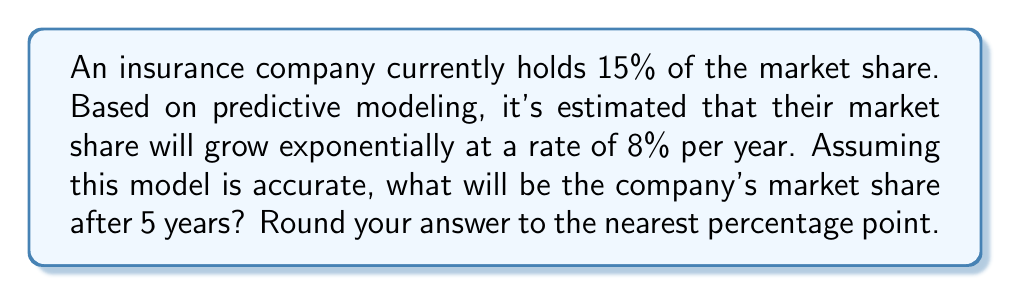Can you answer this question? To solve this problem, we'll use the exponential growth formula:

$$ A = P(1 + r)^t $$

Where:
$A$ = Final amount
$P$ = Initial amount (starting market share)
$r$ = Growth rate (as a decimal)
$t$ = Time period

Given:
$P = 15\%$ (or 0.15 as a decimal)
$r = 8\%$ (or 0.08 as a decimal)
$t = 5$ years

Let's plug these values into the formula:

$$ A = 0.15(1 + 0.08)^5 $$

Now, let's calculate step-by-step:

1) First, calculate $(1 + 0.08)^5$:
   $$ (1.08)^5 = 1.46933 $$

2) Multiply this result by the initial market share:
   $$ 0.15 \times 1.46933 = 0.220399 $$

3) Convert to a percentage:
   $$ 0.220399 \times 100\% = 22.0399\% $$

4) Round to the nearest percentage point:
   $$ 22.0399\% \approx 22\% $$

Therefore, after 5 years, the company's market share is estimated to be 22%.
Answer: 22% 